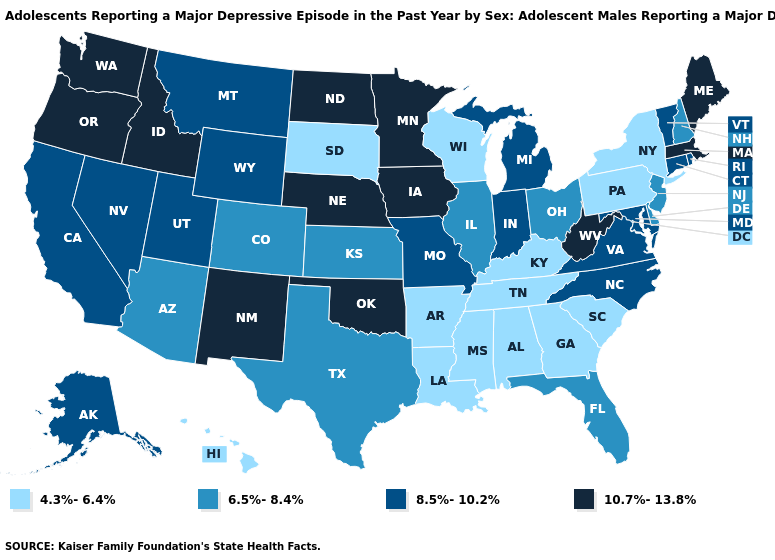Name the states that have a value in the range 8.5%-10.2%?
Keep it brief. Alaska, California, Connecticut, Indiana, Maryland, Michigan, Missouri, Montana, Nevada, North Carolina, Rhode Island, Utah, Vermont, Virginia, Wyoming. Name the states that have a value in the range 10.7%-13.8%?
Answer briefly. Idaho, Iowa, Maine, Massachusetts, Minnesota, Nebraska, New Mexico, North Dakota, Oklahoma, Oregon, Washington, West Virginia. Name the states that have a value in the range 6.5%-8.4%?
Concise answer only. Arizona, Colorado, Delaware, Florida, Illinois, Kansas, New Hampshire, New Jersey, Ohio, Texas. What is the lowest value in the USA?
Concise answer only. 4.3%-6.4%. Name the states that have a value in the range 6.5%-8.4%?
Short answer required. Arizona, Colorado, Delaware, Florida, Illinois, Kansas, New Hampshire, New Jersey, Ohio, Texas. Name the states that have a value in the range 10.7%-13.8%?
Be succinct. Idaho, Iowa, Maine, Massachusetts, Minnesota, Nebraska, New Mexico, North Dakota, Oklahoma, Oregon, Washington, West Virginia. What is the highest value in the MidWest ?
Write a very short answer. 10.7%-13.8%. Is the legend a continuous bar?
Be succinct. No. What is the highest value in the MidWest ?
Short answer required. 10.7%-13.8%. Does Maine have the same value as Minnesota?
Short answer required. Yes. Does Alaska have a higher value than Florida?
Quick response, please. Yes. Name the states that have a value in the range 8.5%-10.2%?
Write a very short answer. Alaska, California, Connecticut, Indiana, Maryland, Michigan, Missouri, Montana, Nevada, North Carolina, Rhode Island, Utah, Vermont, Virginia, Wyoming. Which states have the highest value in the USA?
Quick response, please. Idaho, Iowa, Maine, Massachusetts, Minnesota, Nebraska, New Mexico, North Dakota, Oklahoma, Oregon, Washington, West Virginia. How many symbols are there in the legend?
Keep it brief. 4. Name the states that have a value in the range 6.5%-8.4%?
Quick response, please. Arizona, Colorado, Delaware, Florida, Illinois, Kansas, New Hampshire, New Jersey, Ohio, Texas. 